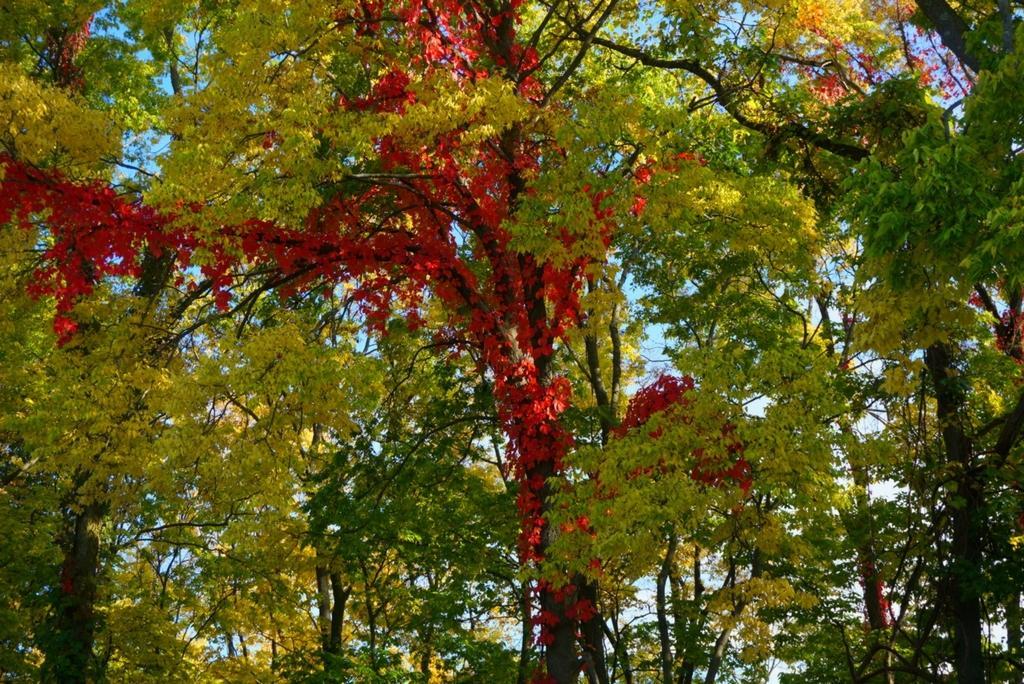Could you give a brief overview of what you see in this image? In this picture we can see trees and in the background we can see the sky. 